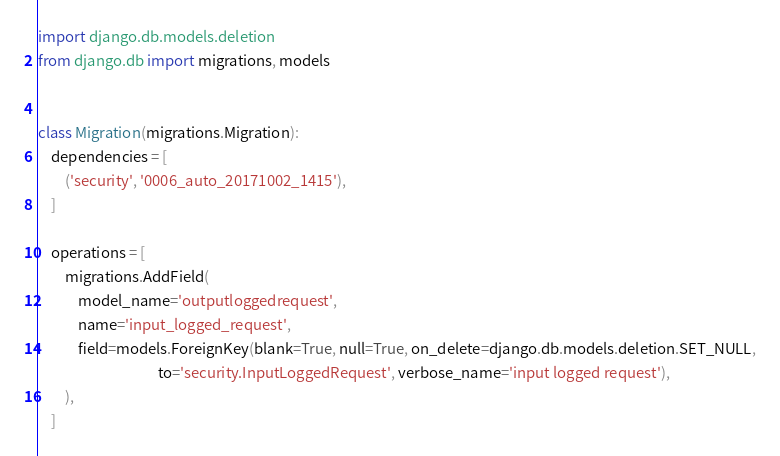<code> <loc_0><loc_0><loc_500><loc_500><_Python_>import django.db.models.deletion
from django.db import migrations, models


class Migration(migrations.Migration):
    dependencies = [
        ('security', '0006_auto_20171002_1415'),
    ]

    operations = [
        migrations.AddField(
            model_name='outputloggedrequest',
            name='input_logged_request',
            field=models.ForeignKey(blank=True, null=True, on_delete=django.db.models.deletion.SET_NULL,
                                    to='security.InputLoggedRequest', verbose_name='input logged request'),
        ),
    ]
</code> 